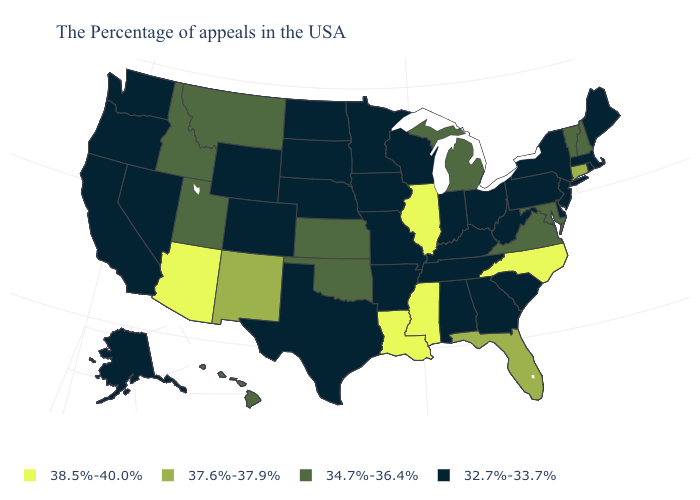What is the highest value in the USA?
Write a very short answer. 38.5%-40.0%. What is the value of New York?
Give a very brief answer. 32.7%-33.7%. Among the states that border Alabama , does Tennessee have the highest value?
Keep it brief. No. What is the value of Kansas?
Short answer required. 34.7%-36.4%. What is the value of Hawaii?
Keep it brief. 34.7%-36.4%. Name the states that have a value in the range 34.7%-36.4%?
Quick response, please. New Hampshire, Vermont, Maryland, Virginia, Michigan, Kansas, Oklahoma, Utah, Montana, Idaho, Hawaii. Does the first symbol in the legend represent the smallest category?
Write a very short answer. No. Which states have the lowest value in the USA?
Keep it brief. Maine, Massachusetts, Rhode Island, New York, New Jersey, Delaware, Pennsylvania, South Carolina, West Virginia, Ohio, Georgia, Kentucky, Indiana, Alabama, Tennessee, Wisconsin, Missouri, Arkansas, Minnesota, Iowa, Nebraska, Texas, South Dakota, North Dakota, Wyoming, Colorado, Nevada, California, Washington, Oregon, Alaska. What is the highest value in the South ?
Be succinct. 38.5%-40.0%. What is the highest value in the USA?
Answer briefly. 38.5%-40.0%. Does Georgia have the same value as Alabama?
Keep it brief. Yes. Among the states that border Mississippi , does Louisiana have the highest value?
Quick response, please. Yes. What is the highest value in states that border Oregon?
Be succinct. 34.7%-36.4%. Does Arizona have the highest value in the USA?
Keep it brief. Yes. Name the states that have a value in the range 34.7%-36.4%?
Give a very brief answer. New Hampshire, Vermont, Maryland, Virginia, Michigan, Kansas, Oklahoma, Utah, Montana, Idaho, Hawaii. 